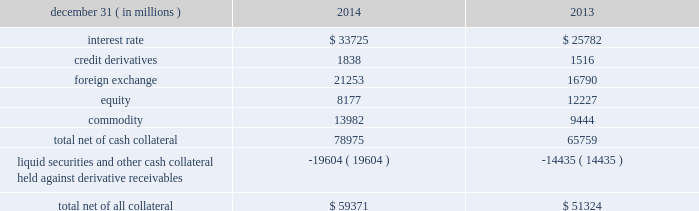Jpmorgan chase & co./2014 annual report 125 lending-related commitments the firm uses lending-related financial instruments , such as commitments ( including revolving credit facilities ) and guarantees , to meet the financing needs of its customers .
The contractual amounts of these financial instruments represent the maximum possible credit risk should the counterparties draw down on these commitments or the firm fulfills its obligations under these guarantees , and the counterparties subsequently fail to perform according to the terms of these contracts .
In the firm 2019s view , the total contractual amount of these wholesale lending-related commitments is not representative of the firm 2019s actual future credit exposure or funding requirements .
In determining the amount of credit risk exposure the firm has to wholesale lending-related commitments , which is used as the basis for allocating credit risk capital to these commitments , the firm has established a 201cloan-equivalent 201d amount for each commitment ; this amount represents the portion of the unused commitment or other contingent exposure that is expected , based on average portfolio historical experience , to become drawn upon in an event of a default by an obligor .
The loan-equivalent amount of the firm 2019s lending- related commitments was $ 229.6 billion and $ 218.9 billion as of december 31 , 2014 and 2013 , respectively .
Clearing services the firm provides clearing services for clients entering into securities and derivative transactions .
Through the provision of these services the firm is exposed to the risk of non-performance by its clients and may be required to share in losses incurred by central counterparties ( 201cccps 201d ) .
Where possible , the firm seeks to mitigate its credit risk to its clients through the collection of adequate margin at inception and throughout the life of the transactions and can also cease provision of clearing services if clients do not adhere to their obligations under the clearing agreement .
For further discussion of clearing services , see note 29 .
Derivative contracts in the normal course of business , the firm uses derivative instruments predominantly for market-making activities .
Derivatives enable customers to manage exposures to fluctuations in interest rates , currencies and other markets .
The firm also uses derivative instruments to manage its own credit exposure .
The nature of the counterparty and the settlement mechanism of the derivative affect the credit risk to which the firm is exposed .
For otc derivatives the firm is exposed to the credit risk of the derivative counterparty .
For exchange-traded derivatives ( 201cetd 201d ) such as futures and options , and 201ccleared 201d over-the-counter ( 201cotc-cleared 201d ) derivatives , the firm is generally exposed to the credit risk of the relevant ccp .
Where possible , the firm seeks to mitigate its credit risk exposures arising from derivative transactions through the use of legally enforceable master netting arrangements and collateral agreements .
For further discussion of derivative contracts , counterparties and settlement types , see note 6 .
The table summarizes the net derivative receivables for the periods presented .
Derivative receivables .
Derivative receivables reported on the consolidated balance sheets were $ 79.0 billion and $ 65.8 billion at december 31 , 2014 and 2013 , respectively .
These amounts represent the fair value of the derivative contracts , after giving effect to legally enforceable master netting agreements and cash collateral held by the firm .
However , in management 2019s view , the appropriate measure of current credit risk should also take into consideration additional liquid securities ( primarily u.s .
Government and agency securities and other g7 government bonds ) and other cash collateral held by the firm aggregating $ 19.6 billion and $ 14.4 billion at december 31 , 2014 and 2013 , respectively , that may be used as security when the fair value of the client 2019s exposure is in the firm 2019s favor .
In addition to the collateral described in the preceding paragraph , the firm also holds additional collateral ( primarily : cash ; g7 government securities ; other liquid government-agency and guaranteed securities ; and corporate debt and equity securities ) delivered by clients at the initiation of transactions , as well as collateral related to contracts that have a non-daily call frequency and collateral that the firm has agreed to return but has not yet settled as of the reporting date .
Although this collateral does not reduce the balances and is not included in the table above , it is available as security against potential exposure that could arise should the fair value of the client 2019s derivative transactions move in the firm 2019s favor .
As of december 31 , 2014 and 2013 , the firm held $ 48.6 billion and $ 50.8 billion , respectively , of this additional collateral .
The prior period amount has been revised to conform with the current period presentation .
The derivative receivables fair value , net of all collateral , also does not include other credit enhancements , such as letters of credit .
For additional information on the firm 2019s use of collateral agreements , see note 6. .
What percent of net derivative receivables were collateralized by other than cash in 2013?\\n? 
Computations: (14435 / 65759)
Answer: 0.21951. 